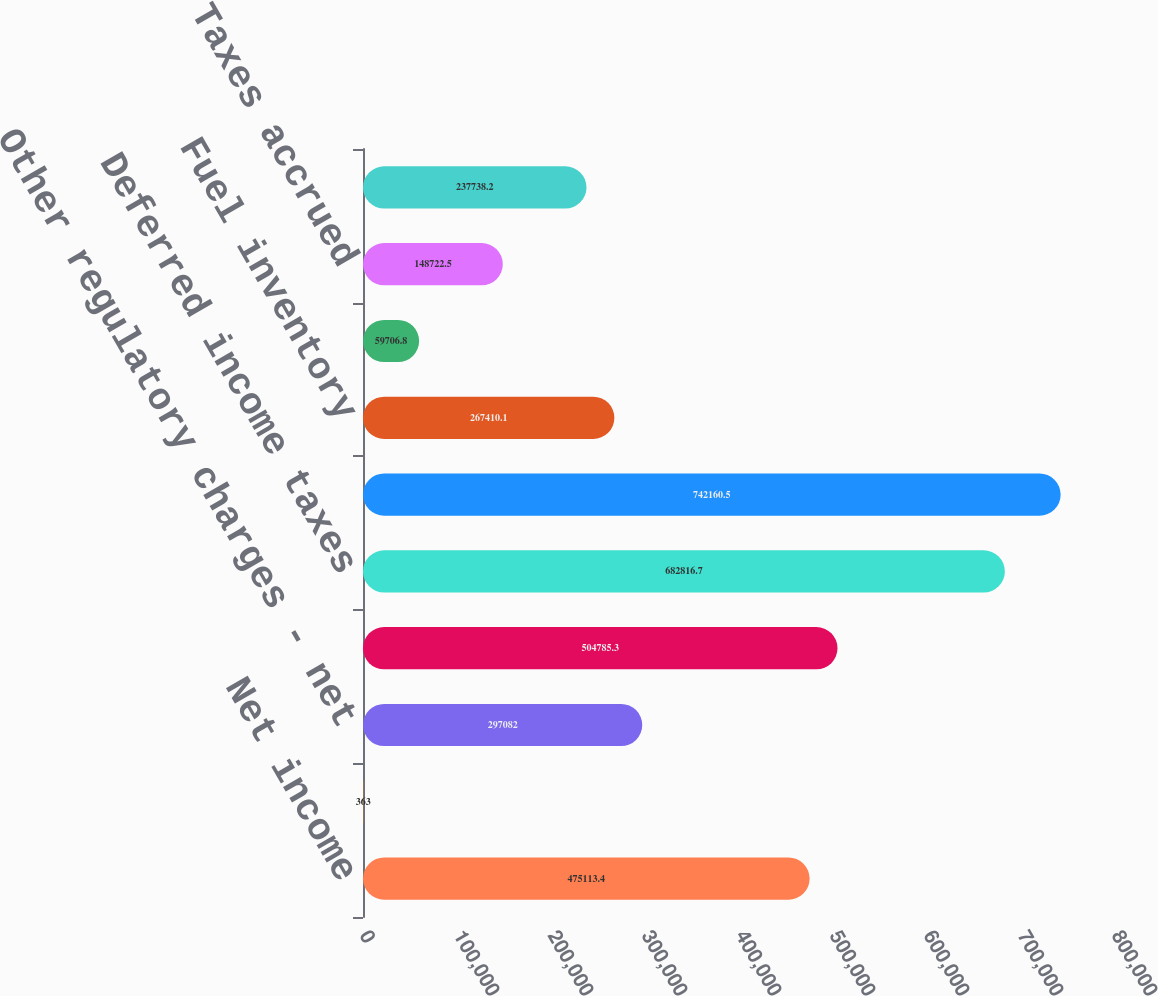Convert chart. <chart><loc_0><loc_0><loc_500><loc_500><bar_chart><fcel>Net income<fcel>Reserve for regulatory<fcel>Other regulatory charges - net<fcel>Depreciation amortization and<fcel>Deferred income taxes<fcel>Receivables<fcel>Fuel inventory<fcel>Accounts payable<fcel>Taxes accrued<fcel>Interest accrued<nl><fcel>475113<fcel>363<fcel>297082<fcel>504785<fcel>682817<fcel>742160<fcel>267410<fcel>59706.8<fcel>148722<fcel>237738<nl></chart> 